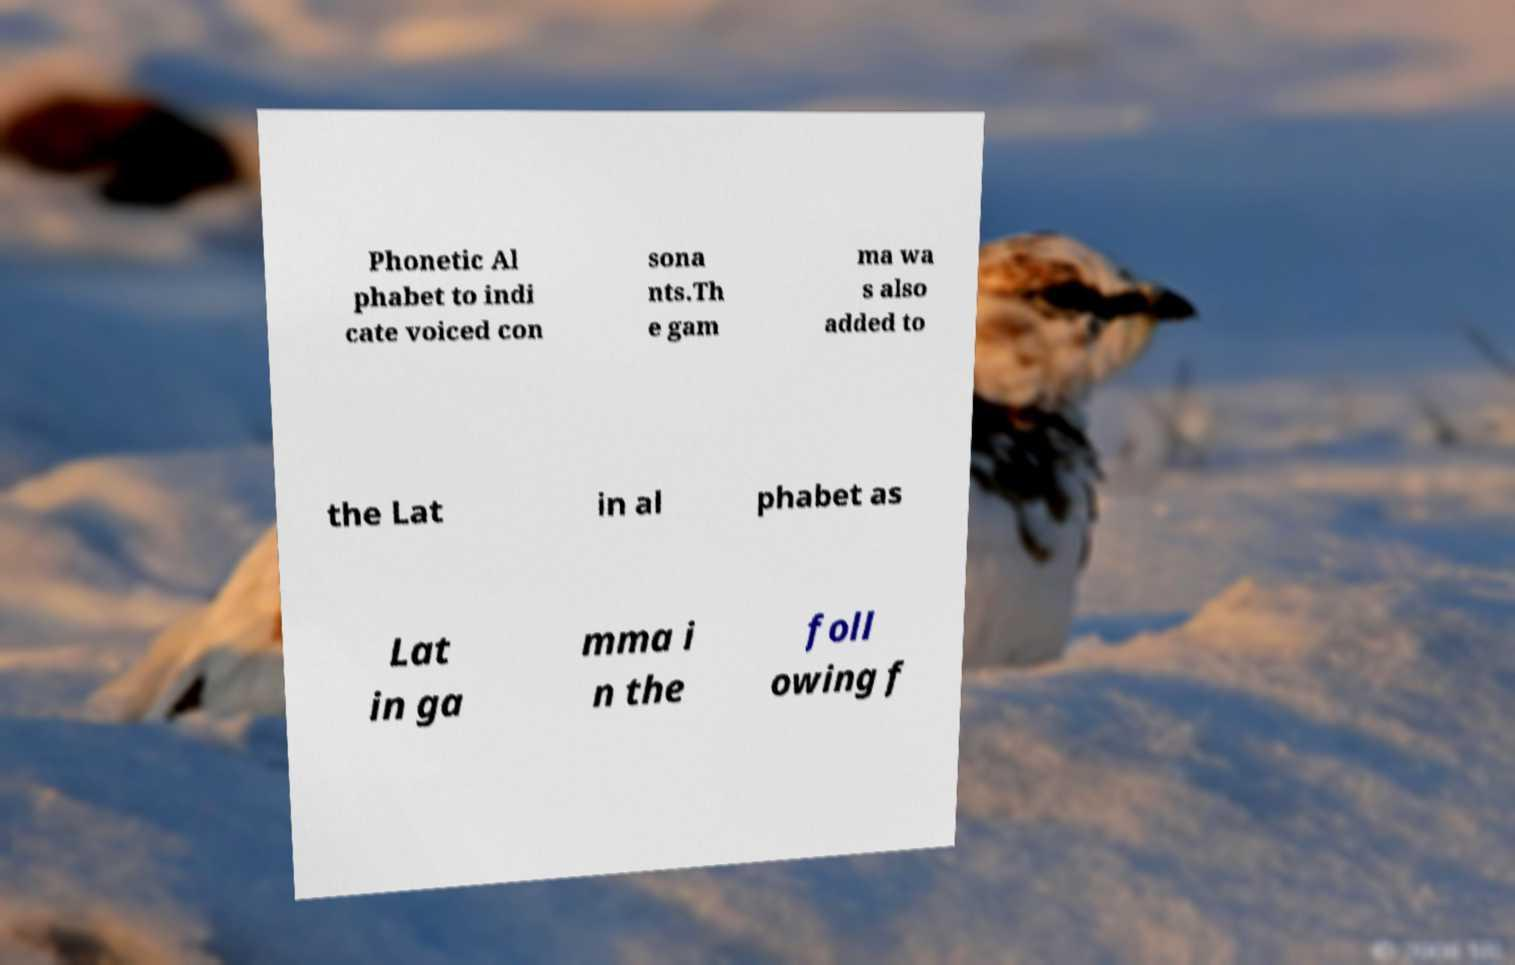Could you assist in decoding the text presented in this image and type it out clearly? Phonetic Al phabet to indi cate voiced con sona nts.Th e gam ma wa s also added to the Lat in al phabet as Lat in ga mma i n the foll owing f 